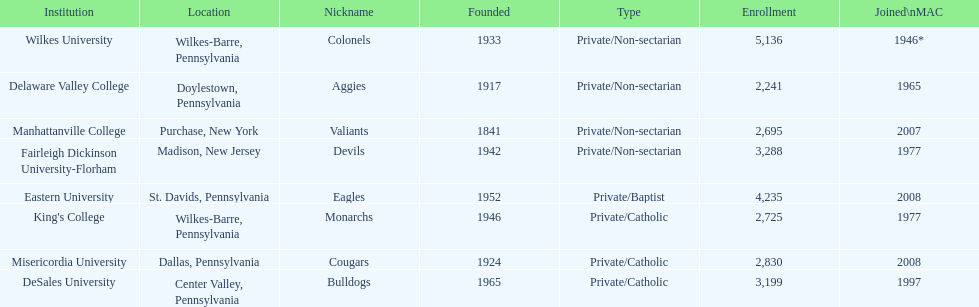Name each institution with enrollment numbers above 4,000? Eastern University, Wilkes University. Can you give me this table as a dict? {'header': ['Institution', 'Location', 'Nickname', 'Founded', 'Type', 'Enrollment', 'Joined\\nMAC'], 'rows': [['Wilkes University', 'Wilkes-Barre, Pennsylvania', 'Colonels', '1933', 'Private/Non-sectarian', '5,136', '1946*'], ['Delaware Valley College', 'Doylestown, Pennsylvania', 'Aggies', '1917', 'Private/Non-sectarian', '2,241', '1965'], ['Manhattanville College', 'Purchase, New York', 'Valiants', '1841', 'Private/Non-sectarian', '2,695', '2007'], ['Fairleigh Dickinson University-Florham', 'Madison, New Jersey', 'Devils', '1942', 'Private/Non-sectarian', '3,288', '1977'], ['Eastern University', 'St. Davids, Pennsylvania', 'Eagles', '1952', 'Private/Baptist', '4,235', '2008'], ["King's College", 'Wilkes-Barre, Pennsylvania', 'Monarchs', '1946', 'Private/Catholic', '2,725', '1977'], ['Misericordia University', 'Dallas, Pennsylvania', 'Cougars', '1924', 'Private/Catholic', '2,830', '2008'], ['DeSales University', 'Center Valley, Pennsylvania', 'Bulldogs', '1965', 'Private/Catholic', '3,199', '1997']]} 